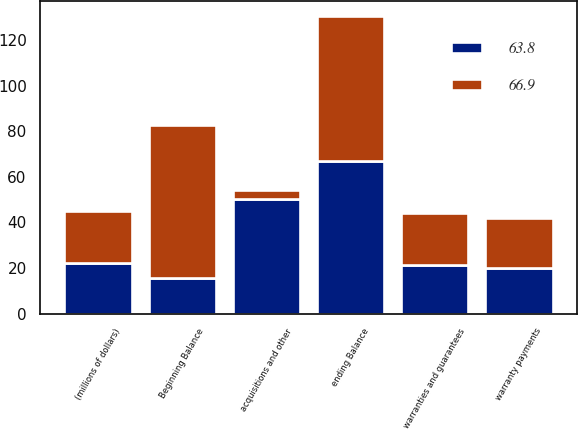Convert chart. <chart><loc_0><loc_0><loc_500><loc_500><stacked_bar_chart><ecel><fcel>(millions of dollars)<fcel>Beginning Balance<fcel>warranties and guarantees<fcel>warranty payments<fcel>acquisitions and other<fcel>ending Balance<nl><fcel>66.9<fcel>22.4<fcel>66.9<fcel>23<fcel>21.8<fcel>4.3<fcel>63.8<nl><fcel>63.8<fcel>22.4<fcel>15.7<fcel>21.3<fcel>20.2<fcel>50.1<fcel>66.9<nl></chart> 